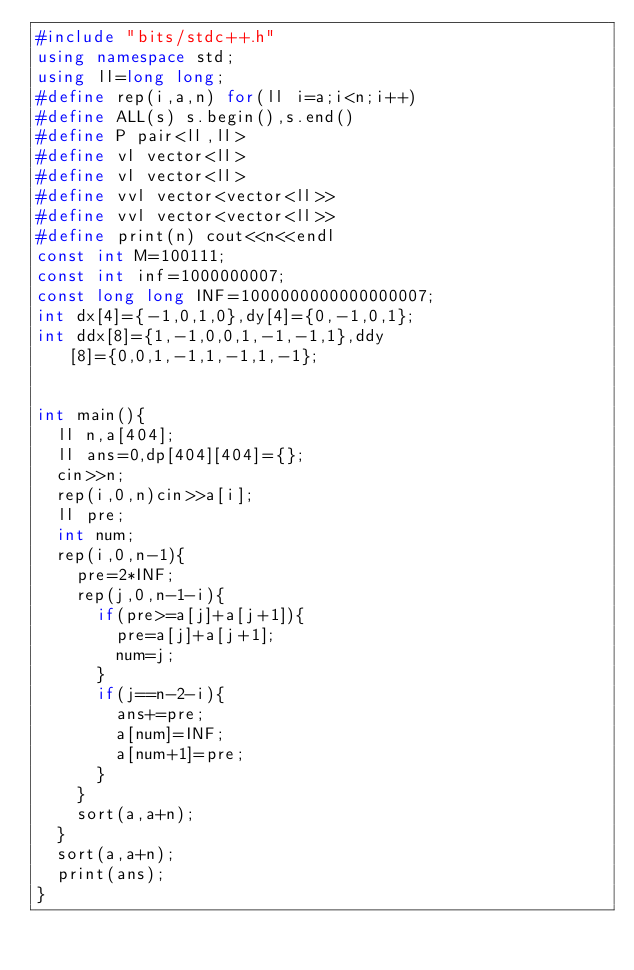Convert code to text. <code><loc_0><loc_0><loc_500><loc_500><_C++_>#include "bits/stdc++.h"
using namespace std;
using ll=long long;
#define rep(i,a,n) for(ll i=a;i<n;i++)
#define ALL(s) s.begin(),s.end()
#define P pair<ll,ll>
#define vl vector<ll>
#define vl vector<ll>
#define vvl vector<vector<ll>>
#define vvl vector<vector<ll>>
#define print(n) cout<<n<<endl
const int M=100111;
const int inf=1000000007;
const long long INF=1000000000000000007;
int dx[4]={-1,0,1,0},dy[4]={0,-1,0,1};
int ddx[8]={1,-1,0,0,1,-1,-1,1},ddy[8]={0,0,1,-1,1,-1,1,-1};


int main(){
	ll n,a[404];
	ll ans=0,dp[404][404]={};
	cin>>n;
	rep(i,0,n)cin>>a[i];
	ll pre;
	int num;
	rep(i,0,n-1){
		pre=2*INF;
		rep(j,0,n-1-i){
			if(pre>=a[j]+a[j+1]){
				pre=a[j]+a[j+1];
				num=j;
			}
			if(j==n-2-i){
				ans+=pre;
				a[num]=INF;
				a[num+1]=pre;
			}
		}
		sort(a,a+n);
	}
	sort(a,a+n);
	print(ans);
}

</code> 